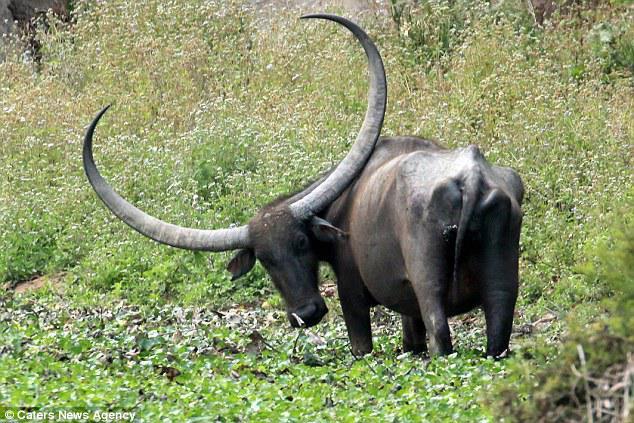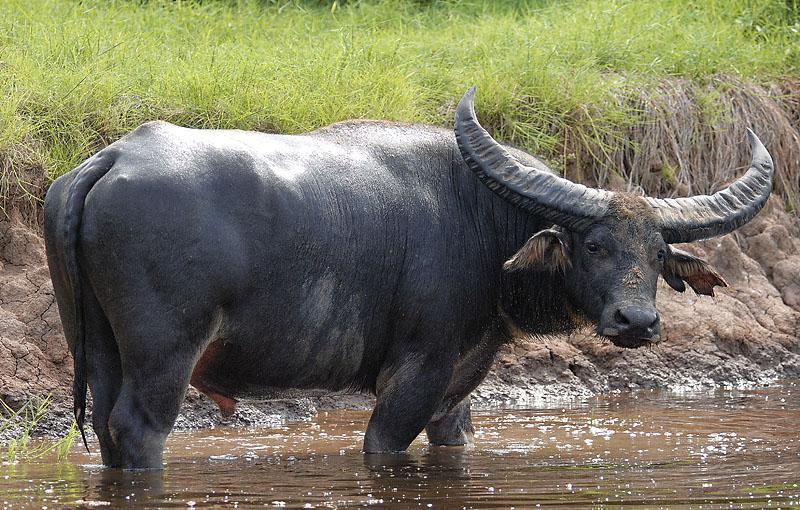The first image is the image on the left, the second image is the image on the right. Considering the images on both sides, is "One animal stands in the grass in the image on the left." valid? Answer yes or no. Yes. The first image is the image on the left, the second image is the image on the right. For the images shown, is this caption "The left image contains more water buffalos than the right image." true? Answer yes or no. No. 